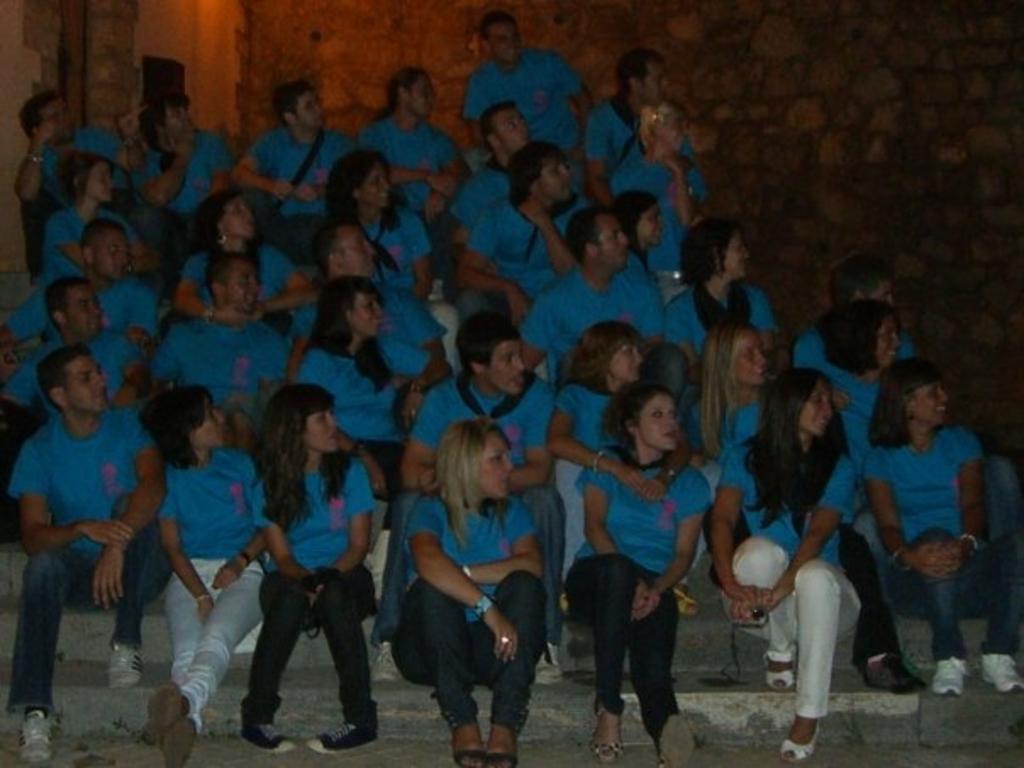Can you describe this image briefly? There are group of people sitting on the stairs. They wore blue T-shirts. This is the wall. 